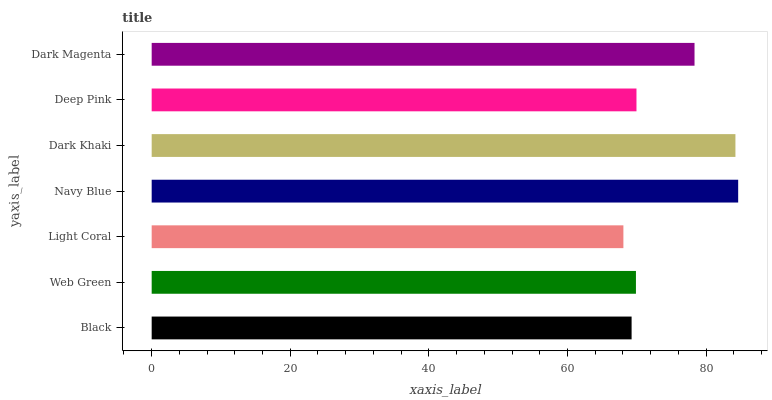Is Light Coral the minimum?
Answer yes or no. Yes. Is Navy Blue the maximum?
Answer yes or no. Yes. Is Web Green the minimum?
Answer yes or no. No. Is Web Green the maximum?
Answer yes or no. No. Is Web Green greater than Black?
Answer yes or no. Yes. Is Black less than Web Green?
Answer yes or no. Yes. Is Black greater than Web Green?
Answer yes or no. No. Is Web Green less than Black?
Answer yes or no. No. Is Deep Pink the high median?
Answer yes or no. Yes. Is Deep Pink the low median?
Answer yes or no. Yes. Is Black the high median?
Answer yes or no. No. Is Black the low median?
Answer yes or no. No. 